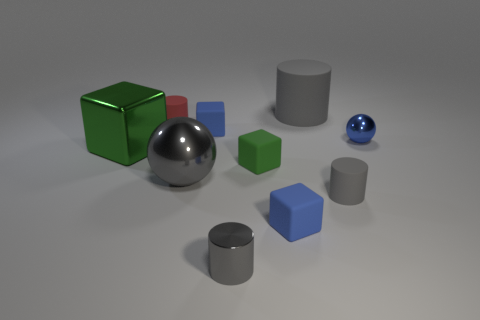Subtract all gray spheres. How many gray cylinders are left? 3 Subtract 1 cylinders. How many cylinders are left? 3 Subtract all purple cubes. Subtract all green spheres. How many cubes are left? 4 Subtract all spheres. How many objects are left? 8 Add 3 big gray shiny things. How many big gray shiny things are left? 4 Add 9 cyan metallic things. How many cyan metallic things exist? 9 Subtract 1 red cylinders. How many objects are left? 9 Subtract all blue matte things. Subtract all cylinders. How many objects are left? 4 